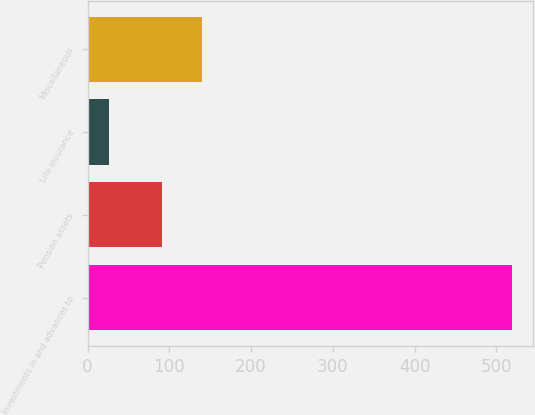<chart> <loc_0><loc_0><loc_500><loc_500><bar_chart><fcel>Investments in and advances to<fcel>Pension assets<fcel>Life insurance<fcel>Miscellaneous<nl><fcel>518.9<fcel>90.9<fcel>26.3<fcel>140.16<nl></chart> 